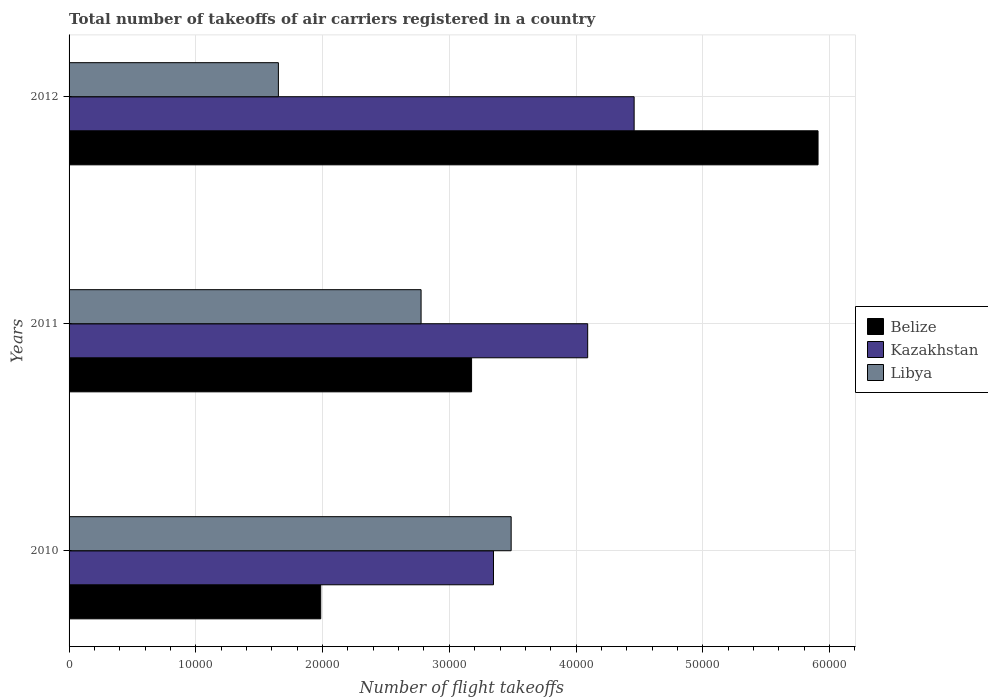Are the number of bars per tick equal to the number of legend labels?
Provide a short and direct response. Yes. What is the total number of flight takeoffs in Libya in 2010?
Make the answer very short. 3.49e+04. Across all years, what is the maximum total number of flight takeoffs in Libya?
Make the answer very short. 3.49e+04. Across all years, what is the minimum total number of flight takeoffs in Belize?
Your answer should be compact. 1.99e+04. In which year was the total number of flight takeoffs in Belize minimum?
Keep it short and to the point. 2010. What is the total total number of flight takeoffs in Belize in the graph?
Provide a succinct answer. 1.11e+05. What is the difference between the total number of flight takeoffs in Libya in 2010 and that in 2012?
Your response must be concise. 1.84e+04. What is the difference between the total number of flight takeoffs in Libya in 2011 and the total number of flight takeoffs in Kazakhstan in 2012?
Keep it short and to the point. -1.68e+04. What is the average total number of flight takeoffs in Libya per year?
Offer a very short reply. 2.64e+04. In the year 2011, what is the difference between the total number of flight takeoffs in Libya and total number of flight takeoffs in Kazakhstan?
Give a very brief answer. -1.31e+04. In how many years, is the total number of flight takeoffs in Belize greater than 58000 ?
Make the answer very short. 1. What is the ratio of the total number of flight takeoffs in Libya in 2010 to that in 2011?
Ensure brevity in your answer.  1.26. Is the total number of flight takeoffs in Kazakhstan in 2011 less than that in 2012?
Provide a succinct answer. Yes. What is the difference between the highest and the second highest total number of flight takeoffs in Libya?
Your response must be concise. 7107.58. What is the difference between the highest and the lowest total number of flight takeoffs in Libya?
Ensure brevity in your answer.  1.84e+04. What does the 2nd bar from the top in 2010 represents?
Provide a succinct answer. Kazakhstan. What does the 3rd bar from the bottom in 2010 represents?
Your answer should be compact. Libya. Is it the case that in every year, the sum of the total number of flight takeoffs in Kazakhstan and total number of flight takeoffs in Libya is greater than the total number of flight takeoffs in Belize?
Make the answer very short. Yes. Are all the bars in the graph horizontal?
Offer a terse response. Yes. Where does the legend appear in the graph?
Offer a very short reply. Center right. What is the title of the graph?
Provide a short and direct response. Total number of takeoffs of air carriers registered in a country. Does "Sudan" appear as one of the legend labels in the graph?
Give a very brief answer. No. What is the label or title of the X-axis?
Keep it short and to the point. Number of flight takeoffs. What is the Number of flight takeoffs of Belize in 2010?
Give a very brief answer. 1.99e+04. What is the Number of flight takeoffs in Kazakhstan in 2010?
Make the answer very short. 3.35e+04. What is the Number of flight takeoffs of Libya in 2010?
Give a very brief answer. 3.49e+04. What is the Number of flight takeoffs of Belize in 2011?
Keep it short and to the point. 3.18e+04. What is the Number of flight takeoffs of Kazakhstan in 2011?
Your answer should be very brief. 4.09e+04. What is the Number of flight takeoffs in Libya in 2011?
Ensure brevity in your answer.  2.78e+04. What is the Number of flight takeoffs in Belize in 2012?
Your answer should be compact. 5.91e+04. What is the Number of flight takeoffs in Kazakhstan in 2012?
Offer a terse response. 4.46e+04. What is the Number of flight takeoffs in Libya in 2012?
Keep it short and to the point. 1.65e+04. Across all years, what is the maximum Number of flight takeoffs in Belize?
Ensure brevity in your answer.  5.91e+04. Across all years, what is the maximum Number of flight takeoffs in Kazakhstan?
Your answer should be very brief. 4.46e+04. Across all years, what is the maximum Number of flight takeoffs of Libya?
Offer a terse response. 3.49e+04. Across all years, what is the minimum Number of flight takeoffs of Belize?
Provide a succinct answer. 1.99e+04. Across all years, what is the minimum Number of flight takeoffs in Kazakhstan?
Your answer should be very brief. 3.35e+04. Across all years, what is the minimum Number of flight takeoffs in Libya?
Your answer should be very brief. 1.65e+04. What is the total Number of flight takeoffs in Belize in the graph?
Your answer should be compact. 1.11e+05. What is the total Number of flight takeoffs in Kazakhstan in the graph?
Your answer should be very brief. 1.19e+05. What is the total Number of flight takeoffs of Libya in the graph?
Provide a succinct answer. 7.92e+04. What is the difference between the Number of flight takeoffs of Belize in 2010 and that in 2011?
Your answer should be very brief. -1.19e+04. What is the difference between the Number of flight takeoffs of Kazakhstan in 2010 and that in 2011?
Provide a short and direct response. -7433. What is the difference between the Number of flight takeoffs in Libya in 2010 and that in 2011?
Ensure brevity in your answer.  7107.58. What is the difference between the Number of flight takeoffs of Belize in 2010 and that in 2012?
Your answer should be compact. -3.92e+04. What is the difference between the Number of flight takeoffs in Kazakhstan in 2010 and that in 2012?
Ensure brevity in your answer.  -1.11e+04. What is the difference between the Number of flight takeoffs of Libya in 2010 and that in 2012?
Offer a very short reply. 1.84e+04. What is the difference between the Number of flight takeoffs in Belize in 2011 and that in 2012?
Your answer should be very brief. -2.73e+04. What is the difference between the Number of flight takeoffs in Kazakhstan in 2011 and that in 2012?
Ensure brevity in your answer.  -3664. What is the difference between the Number of flight takeoffs in Libya in 2011 and that in 2012?
Provide a succinct answer. 1.13e+04. What is the difference between the Number of flight takeoffs in Belize in 2010 and the Number of flight takeoffs in Kazakhstan in 2011?
Your answer should be compact. -2.11e+04. What is the difference between the Number of flight takeoffs in Belize in 2010 and the Number of flight takeoffs in Libya in 2011?
Your response must be concise. -7915.5. What is the difference between the Number of flight takeoffs in Kazakhstan in 2010 and the Number of flight takeoffs in Libya in 2011?
Ensure brevity in your answer.  5712.5. What is the difference between the Number of flight takeoffs of Belize in 2010 and the Number of flight takeoffs of Kazakhstan in 2012?
Keep it short and to the point. -2.47e+04. What is the difference between the Number of flight takeoffs of Belize in 2010 and the Number of flight takeoffs of Libya in 2012?
Your answer should be very brief. 3340.57. What is the difference between the Number of flight takeoffs in Kazakhstan in 2010 and the Number of flight takeoffs in Libya in 2012?
Make the answer very short. 1.70e+04. What is the difference between the Number of flight takeoffs in Belize in 2011 and the Number of flight takeoffs in Kazakhstan in 2012?
Your answer should be very brief. -1.28e+04. What is the difference between the Number of flight takeoffs in Belize in 2011 and the Number of flight takeoffs in Libya in 2012?
Provide a succinct answer. 1.52e+04. What is the difference between the Number of flight takeoffs of Kazakhstan in 2011 and the Number of flight takeoffs of Libya in 2012?
Provide a succinct answer. 2.44e+04. What is the average Number of flight takeoffs in Belize per year?
Your answer should be very brief. 3.69e+04. What is the average Number of flight takeoffs of Kazakhstan per year?
Provide a succinct answer. 3.97e+04. What is the average Number of flight takeoffs in Libya per year?
Give a very brief answer. 2.64e+04. In the year 2010, what is the difference between the Number of flight takeoffs of Belize and Number of flight takeoffs of Kazakhstan?
Give a very brief answer. -1.36e+04. In the year 2010, what is the difference between the Number of flight takeoffs in Belize and Number of flight takeoffs in Libya?
Provide a succinct answer. -1.50e+04. In the year 2010, what is the difference between the Number of flight takeoffs in Kazakhstan and Number of flight takeoffs in Libya?
Your response must be concise. -1395.08. In the year 2011, what is the difference between the Number of flight takeoffs in Belize and Number of flight takeoffs in Kazakhstan?
Provide a succinct answer. -9161. In the year 2011, what is the difference between the Number of flight takeoffs of Belize and Number of flight takeoffs of Libya?
Provide a succinct answer. 3984.5. In the year 2011, what is the difference between the Number of flight takeoffs of Kazakhstan and Number of flight takeoffs of Libya?
Your answer should be very brief. 1.31e+04. In the year 2012, what is the difference between the Number of flight takeoffs of Belize and Number of flight takeoffs of Kazakhstan?
Offer a terse response. 1.45e+04. In the year 2012, what is the difference between the Number of flight takeoffs of Belize and Number of flight takeoffs of Libya?
Keep it short and to the point. 4.26e+04. In the year 2012, what is the difference between the Number of flight takeoffs of Kazakhstan and Number of flight takeoffs of Libya?
Your answer should be very brief. 2.81e+04. What is the ratio of the Number of flight takeoffs in Belize in 2010 to that in 2011?
Your answer should be very brief. 0.63. What is the ratio of the Number of flight takeoffs in Kazakhstan in 2010 to that in 2011?
Offer a very short reply. 0.82. What is the ratio of the Number of flight takeoffs in Libya in 2010 to that in 2011?
Your answer should be compact. 1.26. What is the ratio of the Number of flight takeoffs in Belize in 2010 to that in 2012?
Your answer should be compact. 0.34. What is the ratio of the Number of flight takeoffs of Kazakhstan in 2010 to that in 2012?
Give a very brief answer. 0.75. What is the ratio of the Number of flight takeoffs in Libya in 2010 to that in 2012?
Offer a very short reply. 2.11. What is the ratio of the Number of flight takeoffs of Belize in 2011 to that in 2012?
Offer a very short reply. 0.54. What is the ratio of the Number of flight takeoffs of Kazakhstan in 2011 to that in 2012?
Provide a short and direct response. 0.92. What is the ratio of the Number of flight takeoffs in Libya in 2011 to that in 2012?
Offer a terse response. 1.68. What is the difference between the highest and the second highest Number of flight takeoffs of Belize?
Keep it short and to the point. 2.73e+04. What is the difference between the highest and the second highest Number of flight takeoffs of Kazakhstan?
Keep it short and to the point. 3664. What is the difference between the highest and the second highest Number of flight takeoffs of Libya?
Make the answer very short. 7107.58. What is the difference between the highest and the lowest Number of flight takeoffs of Belize?
Your response must be concise. 3.92e+04. What is the difference between the highest and the lowest Number of flight takeoffs in Kazakhstan?
Your answer should be very brief. 1.11e+04. What is the difference between the highest and the lowest Number of flight takeoffs in Libya?
Make the answer very short. 1.84e+04. 